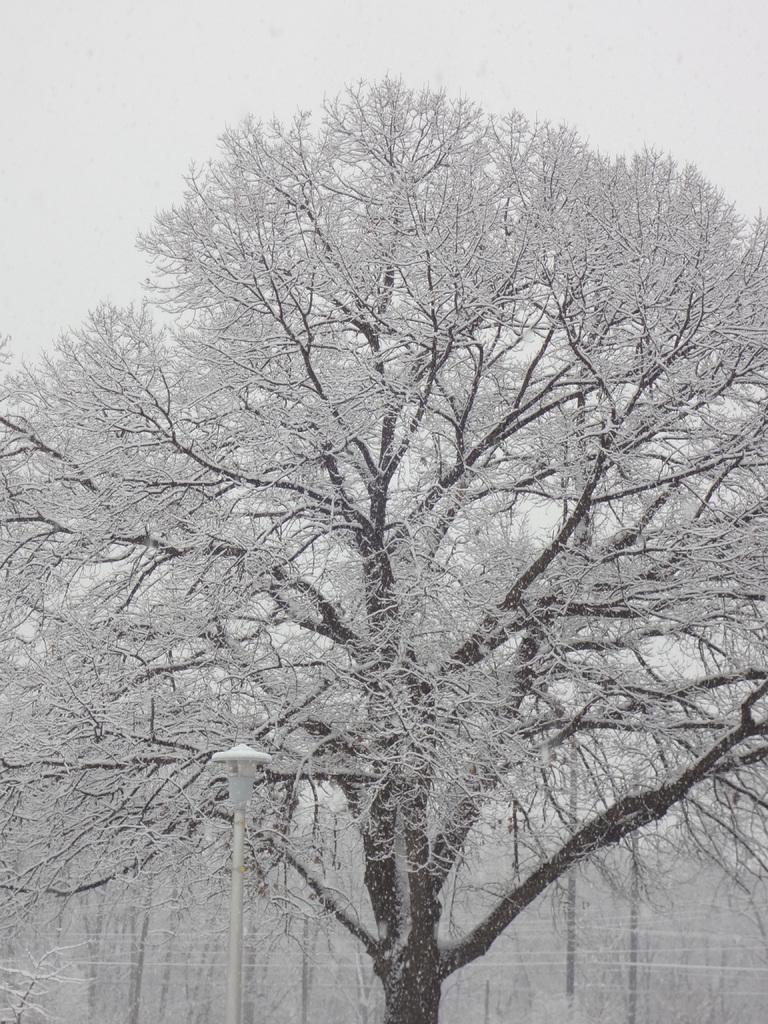What is present in the image? There is a tree in the image. What is covering the tree? The tree has snow on it. What can be observed about the structure of the tree? The tree has branches. What type of sponge is being used to clean the tree in the image? There is no sponge present in the image, and the tree is not being cleaned. 